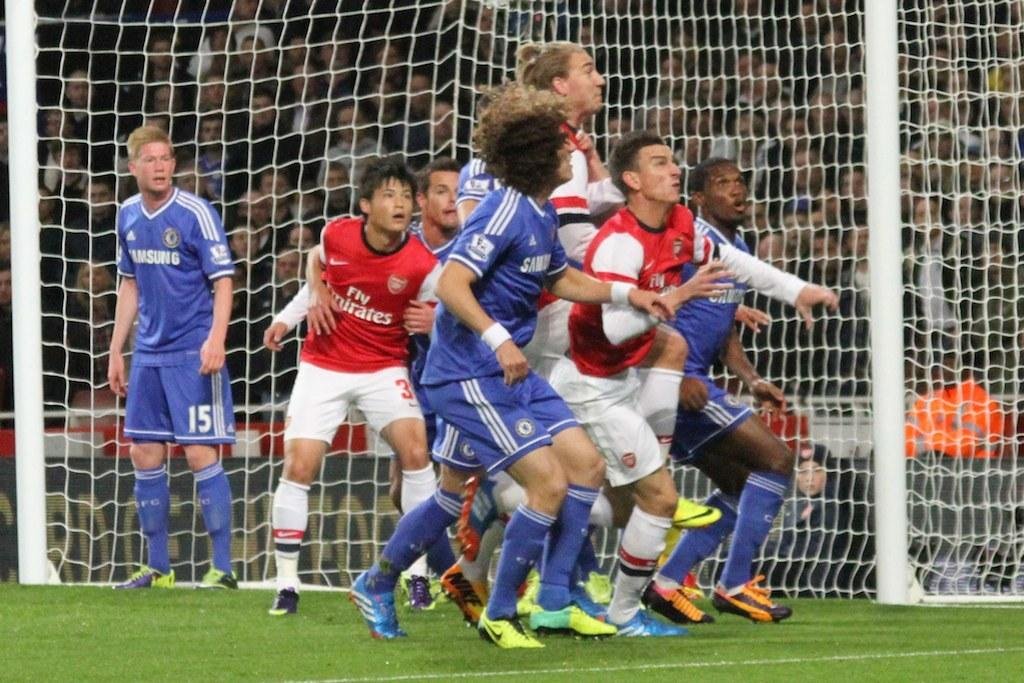<image>
Render a clear and concise summary of the photo. Several soccer players, including one whose jersey reads "Fly Emirates," are in action on the field. 